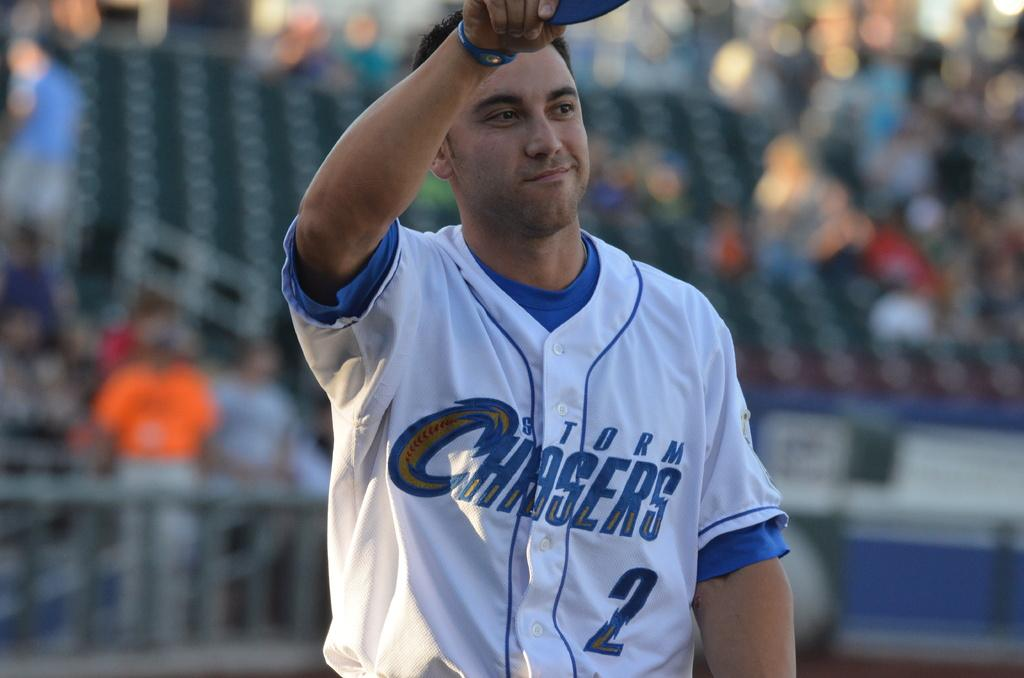Who is the main subject in the image? There is a man in the image. Can you describe the surroundings of the man? There are people and unspecified objects in the background of the image. How would you describe the quality of the image? The image is blurry. What type of expansion is occurring in the image? There is no expansion occurring in the image; it is a still image of a man and his surroundings. 